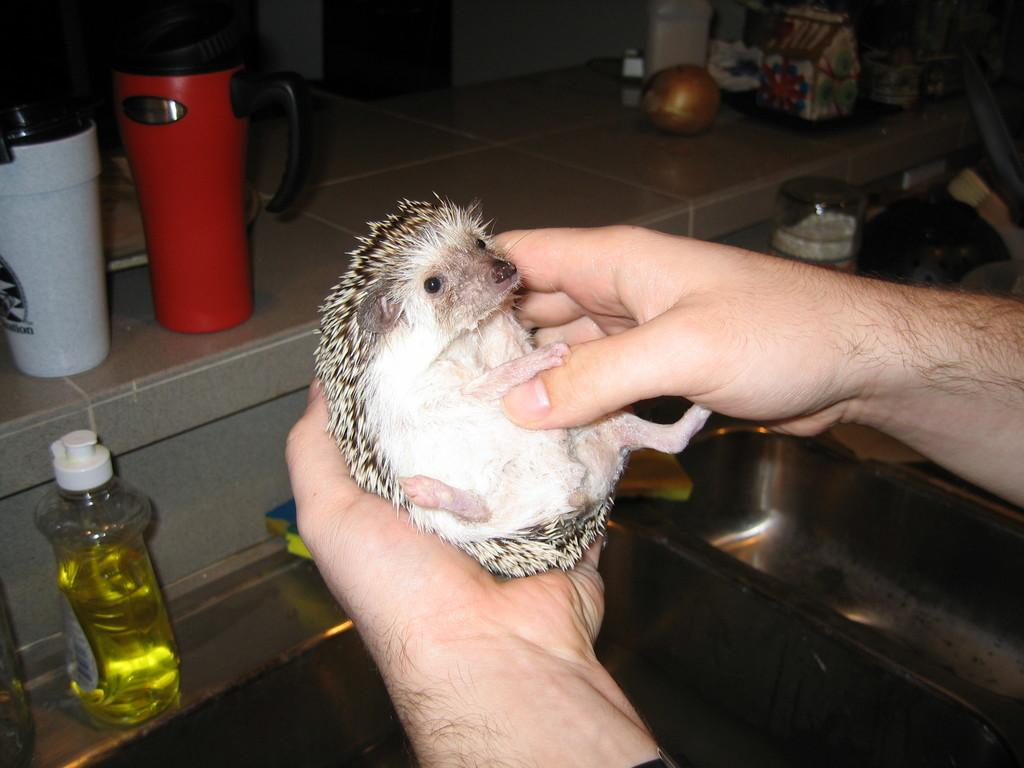What type of animal is in the image? There is an animal in the image, but the specific type is not mentioned in the facts. What is the person in the image doing with the animal? The person is holding the animal. How many bottles are visible in the image? There are two bottles visible in the image. What type of leather is used to make the cat's collar in the image? There is no cat or collar present in the image, so it is not possible to determine the type of leather used. 